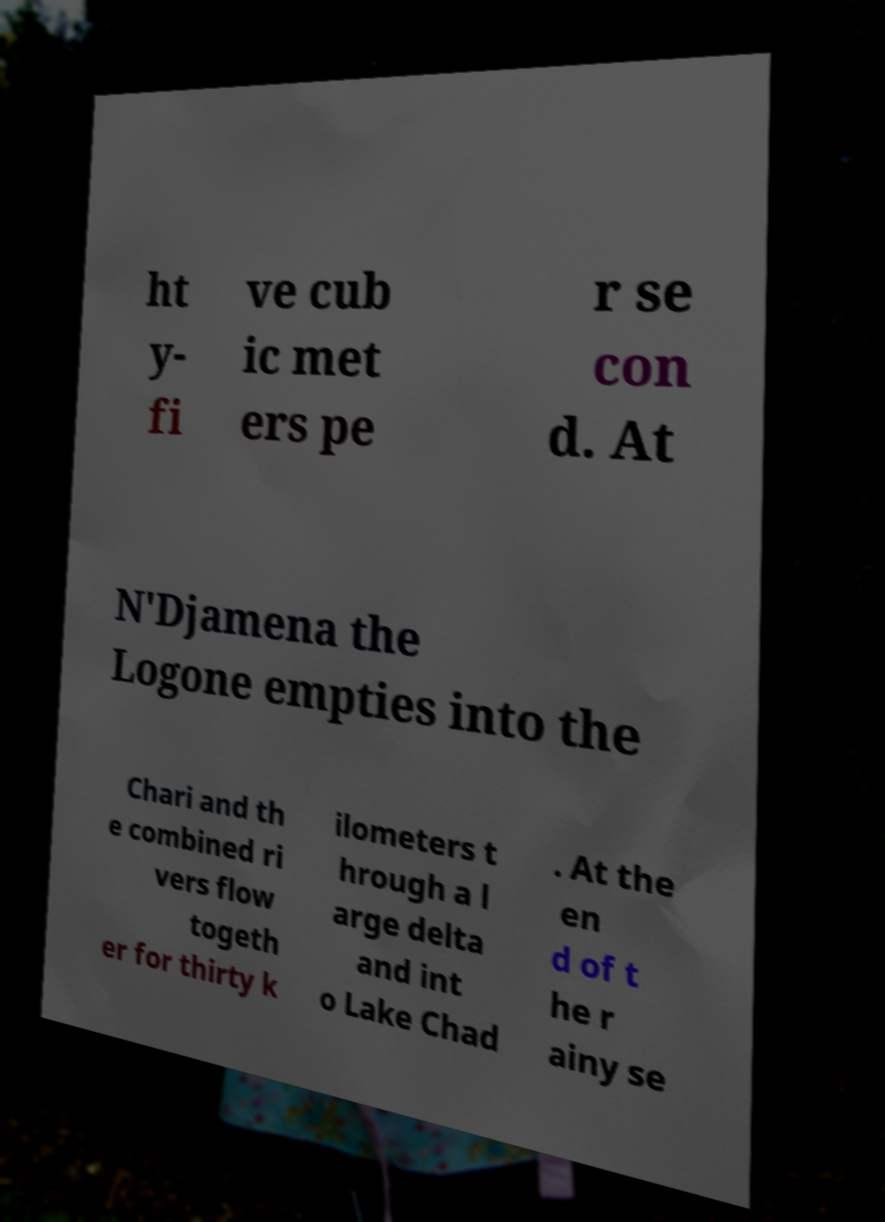Could you assist in decoding the text presented in this image and type it out clearly? ht y- fi ve cub ic met ers pe r se con d. At N'Djamena the Logone empties into the Chari and th e combined ri vers flow togeth er for thirty k ilometers t hrough a l arge delta and int o Lake Chad . At the en d of t he r ainy se 